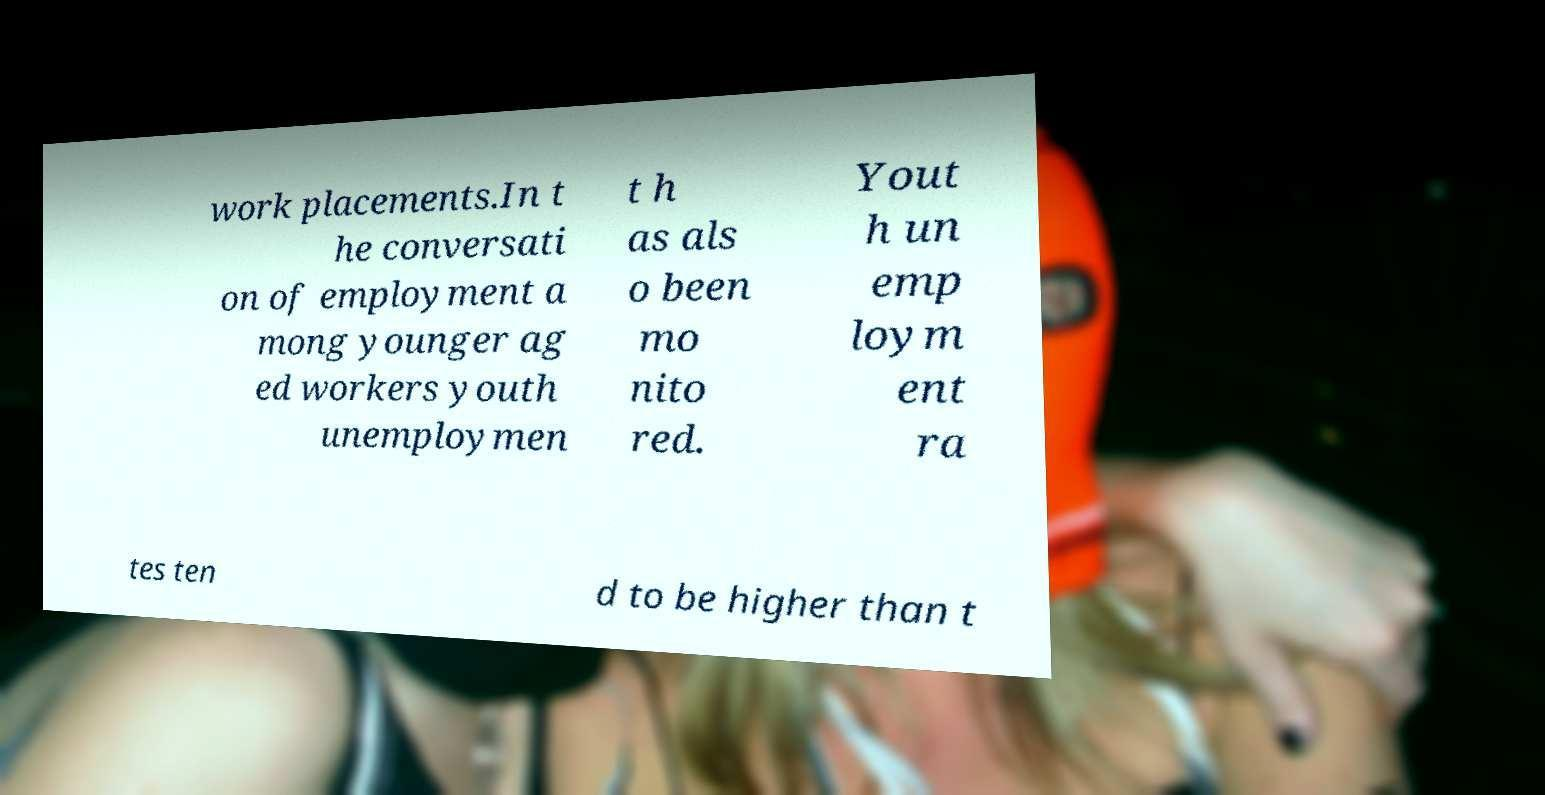For documentation purposes, I need the text within this image transcribed. Could you provide that? work placements.In t he conversati on of employment a mong younger ag ed workers youth unemploymen t h as als o been mo nito red. Yout h un emp loym ent ra tes ten d to be higher than t 